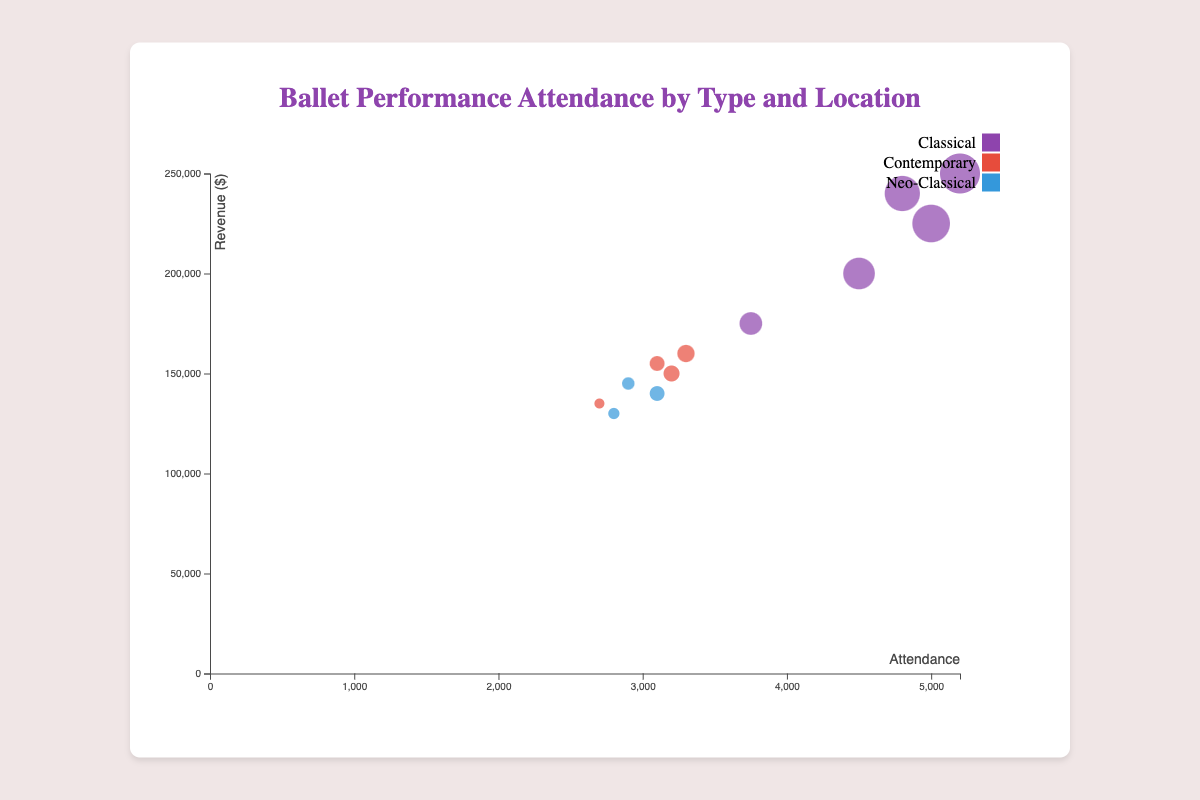What is the title of the chart? The title of the chart is displayed consistently on top and is easy to read.
Answer: Ballet Performance Attendance by Type and Location Which location had the highest attendance for any ballet performance? By observing the bubble sizes, the largest bubble represents Paris in Spring for Classical ballet with an attendance of 5200.
Answer: Paris What type of ballet has the highest attendance in New York City during the Fall season? The bubbles in New York City are distinguished by color, and the largest bubble in the Fall season is Classical ballet with 4500 attendees.
Answer: Classical How many ballet types are represented in the chart? The legend lists the colors representing the different ballet types, noting Classical, Contemporary, and Neo-Classical as the three types.
Answer: 3 Which season in Tokyo has the lowest revenue, and what is that revenue? Of the bubbles for Tokyo, the smallest bubble by height represents Fall for Contemporary ballet, with revenues of $135,000.
Answer: Fall, $135,000 Which location had the highest revenue for a Classical ballet, and what was that revenue? By comparing the heights of the bubbles colored for Classical ballet, Paris in Spring has the highest, showing a revenue of $250,000.
Answer: Paris, $250,000 What is the difference in attendance between the Spring and Winter seasons in San Francisco? Observing the bubbles for San Francisco, Classical ballet in Winter has 3750 attendees and Contemporary ballet in Spring has 3300 attendees, so the difference is 3750 - 3300 = 450.
Answer: 450 Among all the ballet types in London, which season had the lowest attendance? Looking at the bubbles for London, the smallest bubble is Summer for Neo-Classical ballet with an attendance of 3100.
Answer: Summer Compare the attendance of Contemporary ballet in Fall across New York City and Tokyo. Which city had higher attendance and what are the values? Comparing the bubbles for Contemporary ballet in Fall, New York City had 3200 attendees while Tokyo had 2700, indicating New York City had higher attendance.
Answer: New York City, 3200; Tokyo, 2700 What is the total revenue for Classical ballet performances across all locations? Adding the revenues for Classical ballet across all locations: 200000 (NYC Fall) + 225000 (NYC Spring) + 175000 (SF Winter) + 240000 (London Winter) + 250000 (Paris Spring) = $1,090,000.
Answer: $1,090,000 